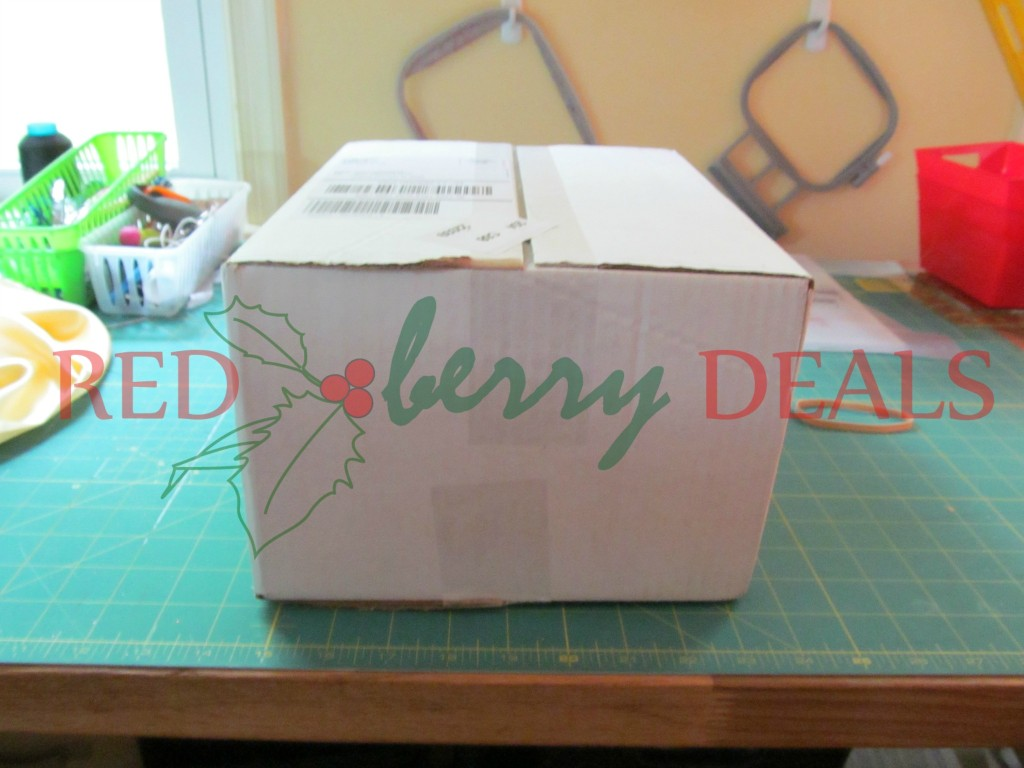Can you describe the background setting in more detail? The background of the image suggests a workspace or a craft room. To the left, there is a window with a pale frame that allows natural light to enter. The rear wall is painted a soft color, possibly beige or light yellow, providing a warm ambiance to the area. Hanging on the wall are some tools or frames, yet their specific designs are somewhat difficult to discern; they appear to be utilitarian objects, perhaps related to handiworks or manufacturing. Overall, the setting appears organized and functional, tailored to work or crafting activities. 